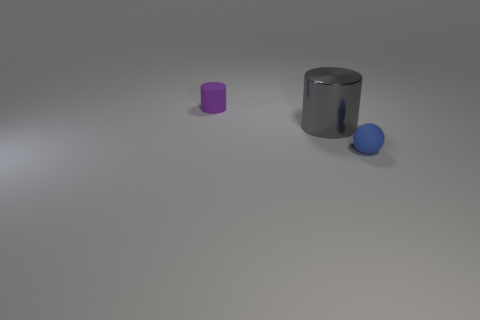Add 3 green cubes. How many objects exist? 6 Subtract all balls. How many objects are left? 2 Subtract all small cyan metallic things. Subtract all purple objects. How many objects are left? 2 Add 3 metal objects. How many metal objects are left? 4 Add 3 gray shiny cylinders. How many gray shiny cylinders exist? 4 Subtract 0 yellow blocks. How many objects are left? 3 